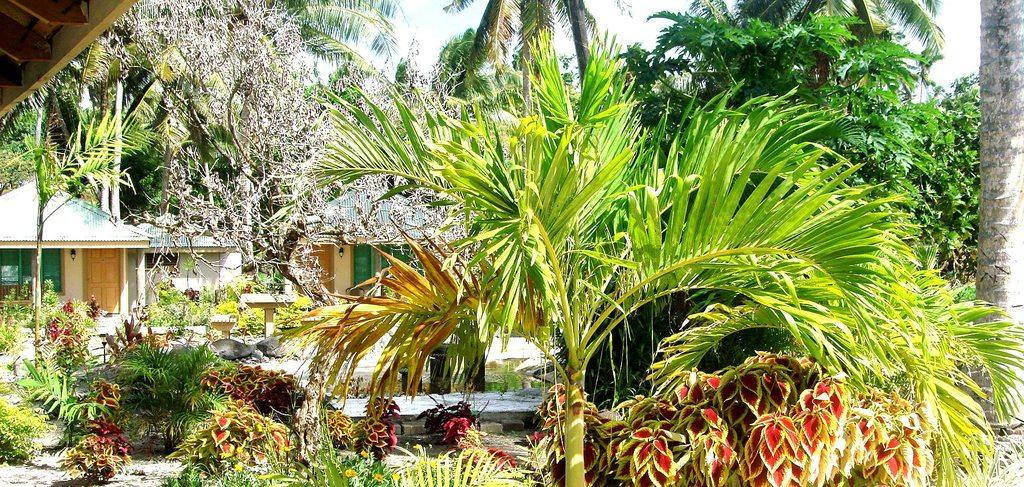What type of vegetation can be seen in the image? There are many trees and plants in the image. What type of structures are visible in the image? There are houses in the image. What part of the natural environment is visible in the image? The sky is visible in the image. What type of hat is the word "sisters" wearing in the image? There is no hat or word "sisters" present in the image. 